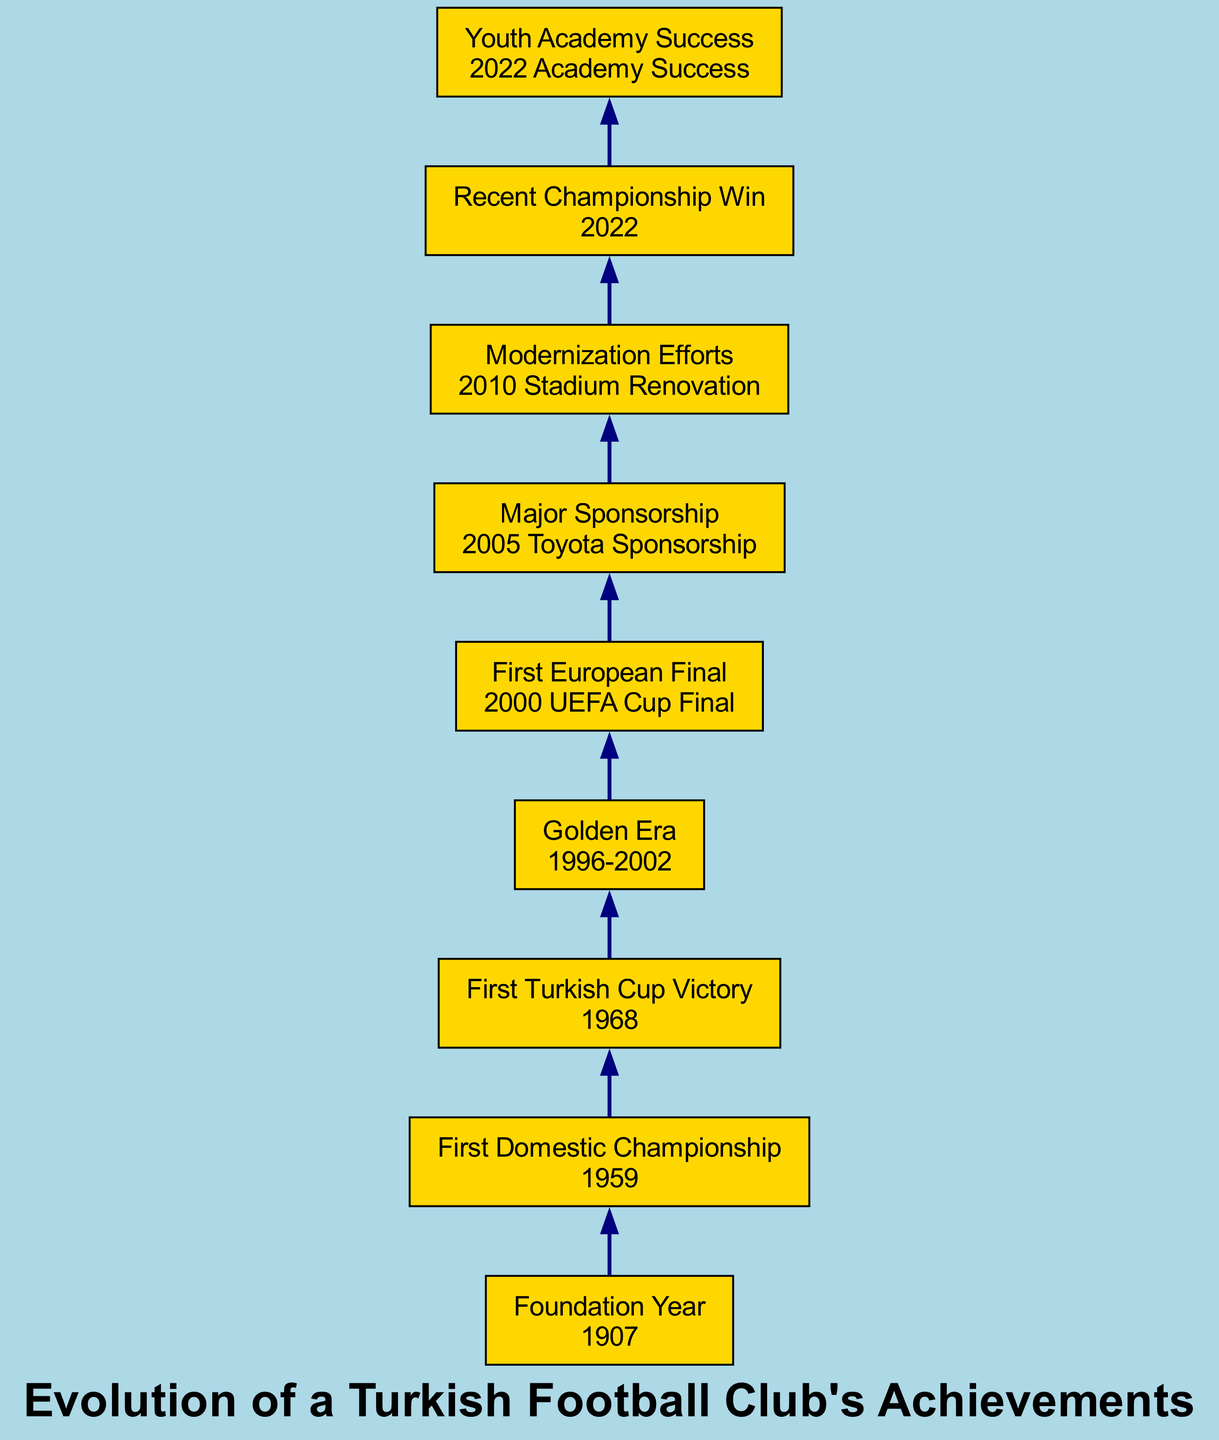What year was the Turkish football club founded? The diagram shows a node labeled "Foundation Year" with the event listed as "1907." Therefore, looking directly at that node provides the answer.
Answer: 1907 What was the first championship the club won? The node titled "First Domestic Championship" indicates that the event associated with it is "1959," showing this was the first championship win.
Answer: Turkish Süper Lig What significant event occurred in 2000? The node labeled "First European Final" specifies "2000 UEFA Cup Final" as the event that took place in that year, indicating its significance.
Answer: 2000 UEFA Cup Final How many significant achievements are listed in the diagram? By counting the nodes in the diagram, there are eight elements: Foundation Year, First Domestic Championship, First Turkish Cup Victory, Golden Era, First European Final, Major Sponsorship, Modernization Efforts, Recent Championship Win, and Youth Academy Success, so the total count is determined by listing them all.
Answer: 8 What is the outcome of the club's "Golden Era"? The node for "Golden Era" describes it as a period of substantial success from 1996 to 2002; thus, correlating this period with achievements leads to recognizing its importance in the club's history.
Answer: 1996-2002 Which achievement directly follows the "Major Sponsorship"? The flow of the diagram indicates direct relationships between nodes, where "Major Sponsorship" connects to the next node, "Modernization Efforts." By tracking this flow, the answer can be determined.
Answer: Modernization Efforts What occurred immediately before the "Recent Championship Win"? The node sequence shows that "Modernization Efforts" comes before the node labeled "Recent Championship Win," thus providing a clear order of achievements in the timeline.
Answer: Modernization Efforts In what year did the club have success with its youth academy? The diagram directly states that the achievement labeled "Youth Academy Success" occurred in 2022, allowing for a straightforward retrieval of information.
Answer: 2022 What major event did the club achieve first in a European competition? Looking at "First European Final," the diagram identifies the event as "2000 UEFA Cup Final," indicating this was the first major European event for the club.
Answer: 2000 UEFA Cup Final 